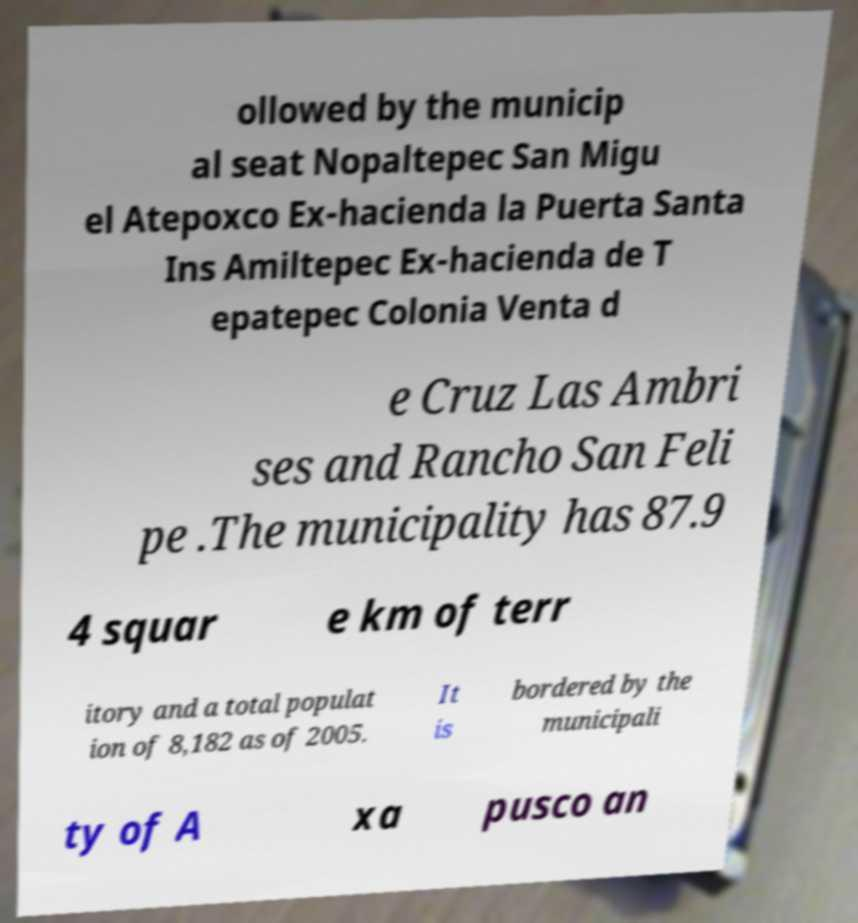What messages or text are displayed in this image? I need them in a readable, typed format. ollowed by the municip al seat Nopaltepec San Migu el Atepoxco Ex-hacienda la Puerta Santa Ins Amiltepec Ex-hacienda de T epatepec Colonia Venta d e Cruz Las Ambri ses and Rancho San Feli pe .The municipality has 87.9 4 squar e km of terr itory and a total populat ion of 8,182 as of 2005. It is bordered by the municipali ty of A xa pusco an 